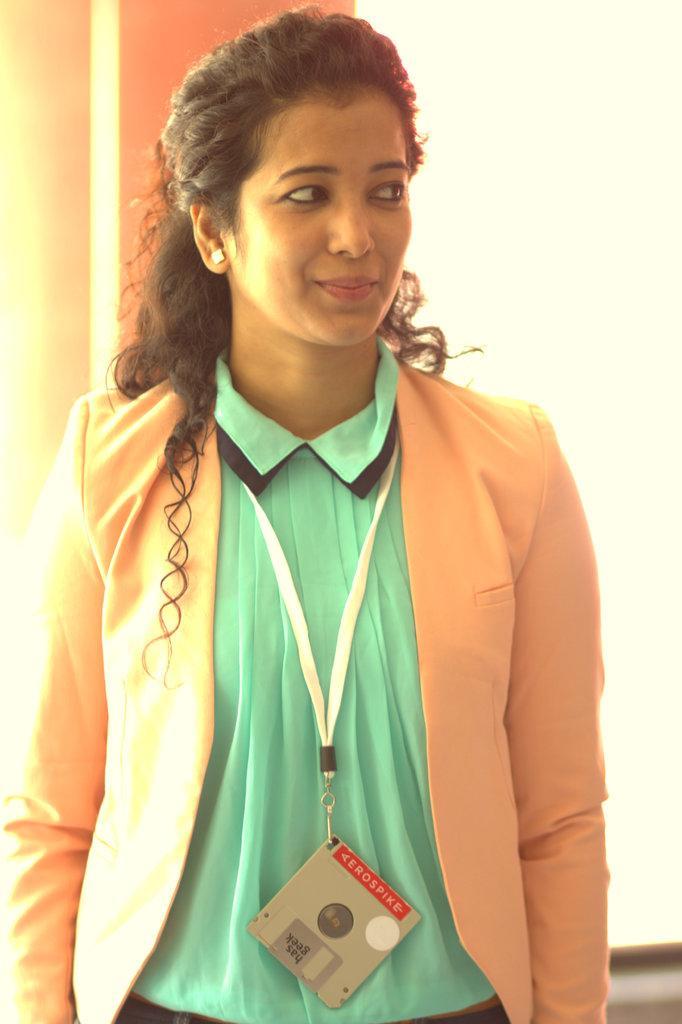In one or two sentences, can you explain what this image depicts? As we can see in the image there is a white color wall and a woman standing. The woman is wearing orange color jacket, green color dress and 